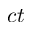Convert formula to latex. <formula><loc_0><loc_0><loc_500><loc_500>c t</formula> 